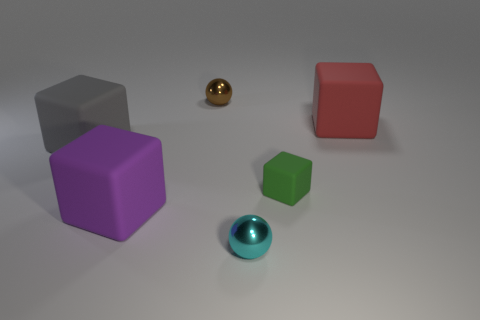Do the metallic sphere in front of the red rubber thing and the green rubber cube have the same size?
Offer a very short reply. Yes. Is there a brown cube that has the same size as the purple object?
Give a very brief answer. No. Is the color of the tiny metal thing that is behind the red thing the same as the large object that is on the right side of the cyan metallic ball?
Ensure brevity in your answer.  No. Is there another small rubber object that has the same color as the small matte thing?
Ensure brevity in your answer.  No. What number of other objects are the same shape as the tiny brown object?
Give a very brief answer. 1. What shape is the big object in front of the big gray rubber thing?
Offer a terse response. Cube. There is a big purple rubber thing; is its shape the same as the large rubber thing that is on the right side of the big purple block?
Your answer should be very brief. Yes. What is the size of the matte object that is on the right side of the cyan metal sphere and in front of the large red rubber object?
Make the answer very short. Small. What is the color of the tiny object that is in front of the large red matte object and behind the cyan ball?
Provide a succinct answer. Green. Is there anything else that is made of the same material as the big purple thing?
Keep it short and to the point. Yes. 